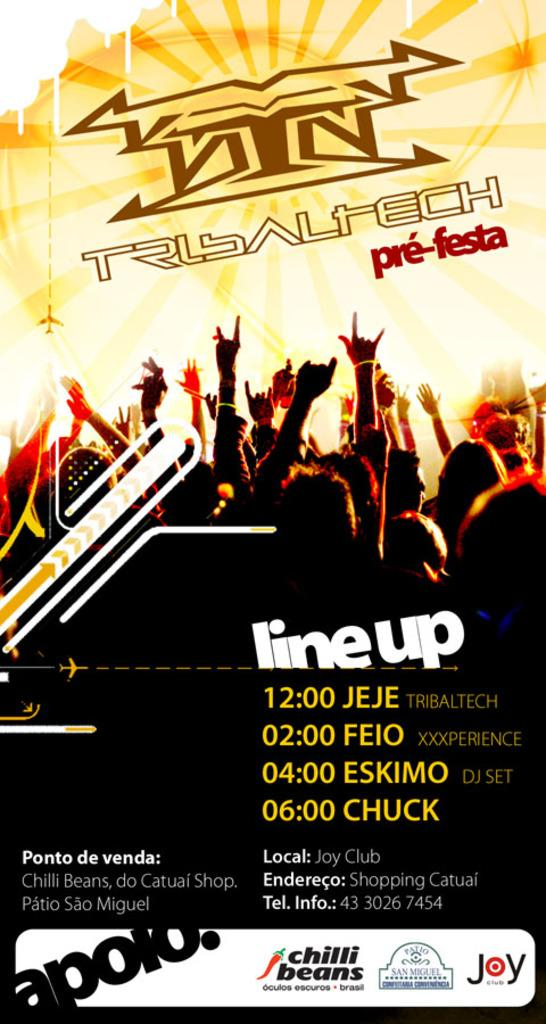<image>
Relay a brief, clear account of the picture shown. Poster for a concert that is taking place at Joy Club. 